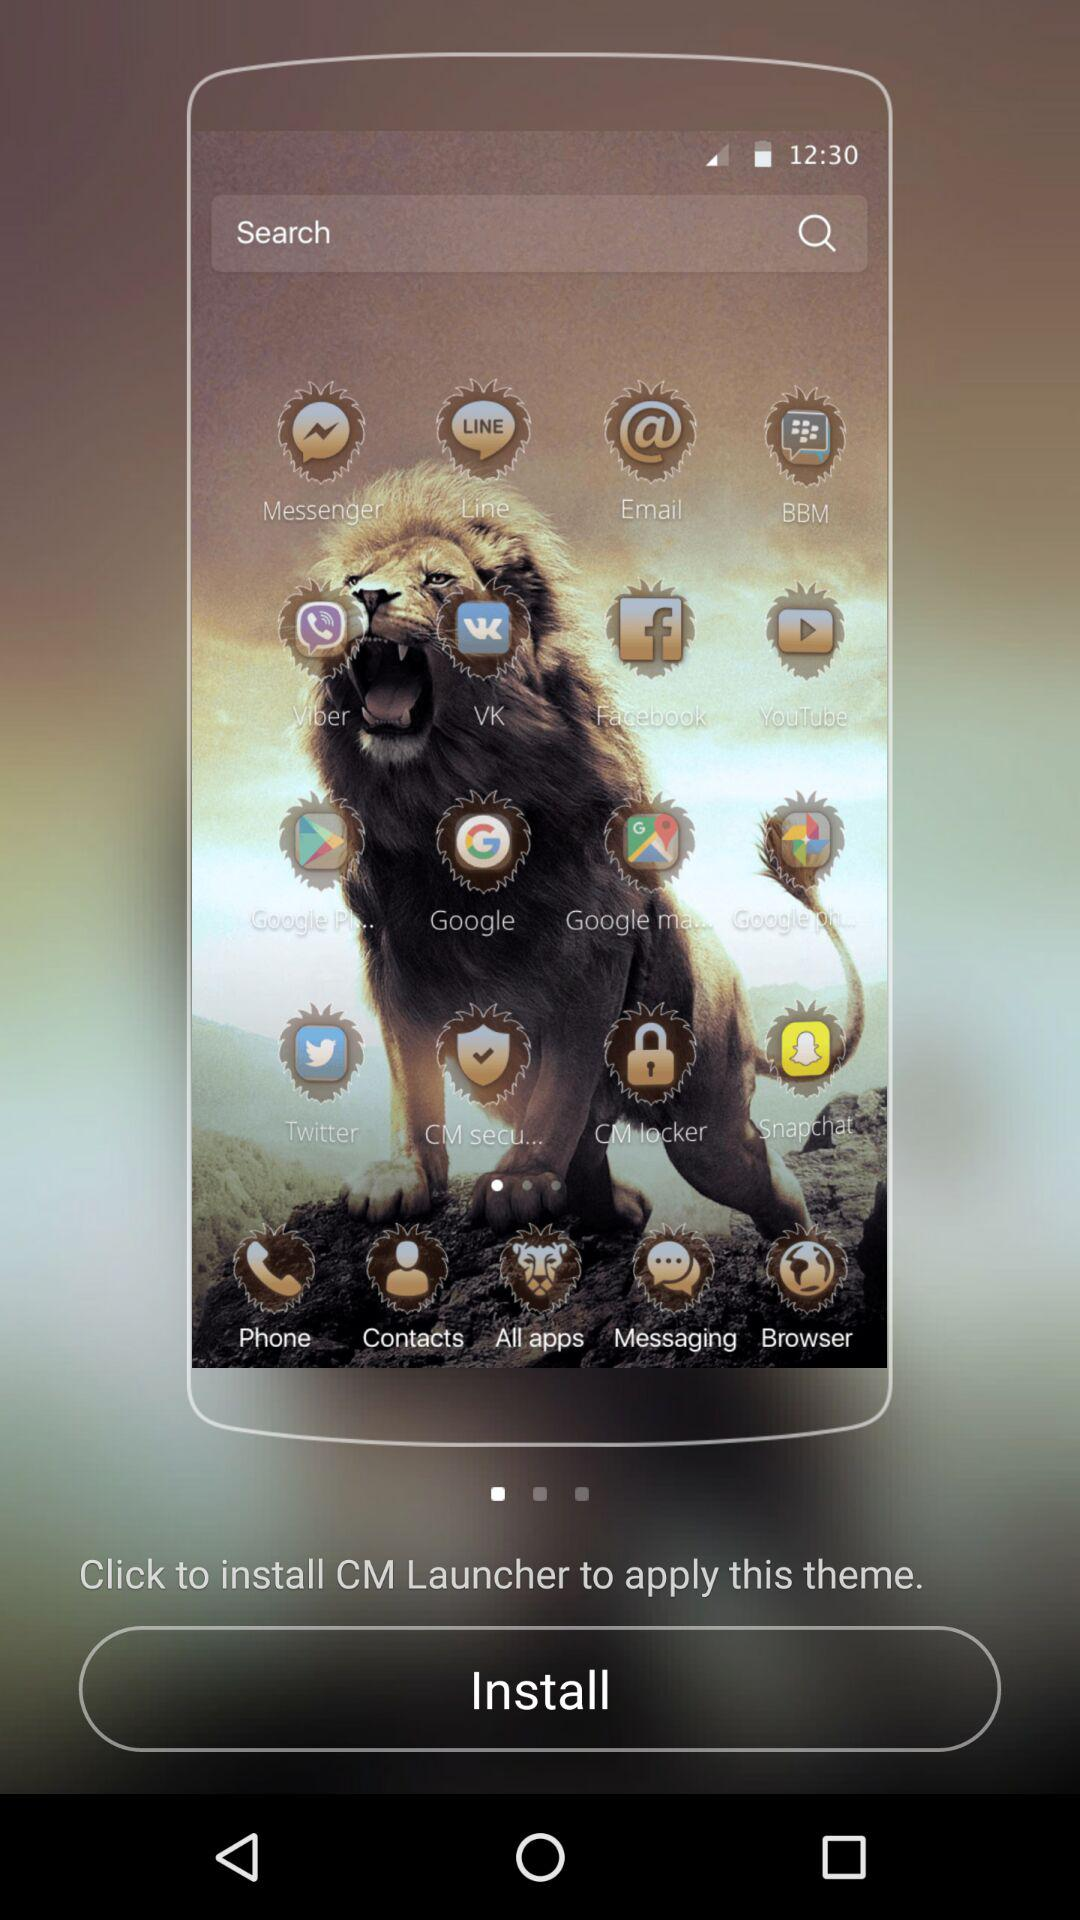What should I do to apply the theme? You should install "CM Launcher" to apply the theme. 